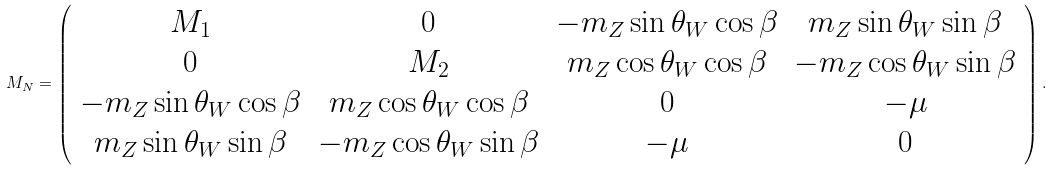Convert formula to latex. <formula><loc_0><loc_0><loc_500><loc_500>M _ { N } = \left ( \begin{array} { c c c c } M _ { 1 } & 0 & - m _ { Z } \sin \theta _ { W } \cos \beta & m _ { Z } \sin \theta _ { W } \sin \beta \\ 0 & M _ { 2 } & m _ { Z } \cos \theta _ { W } \cos \beta & - m _ { Z } \cos \theta _ { W } \sin \beta \\ - m _ { Z } \sin \theta _ { W } \cos \beta & m _ { Z } \cos \theta _ { W } \cos \beta & 0 & - \mu \\ m _ { Z } \sin \theta _ { W } \sin \beta & - m _ { Z } \cos \theta _ { W } \sin \beta & - \mu & 0 \end{array} \right ) .</formula> 